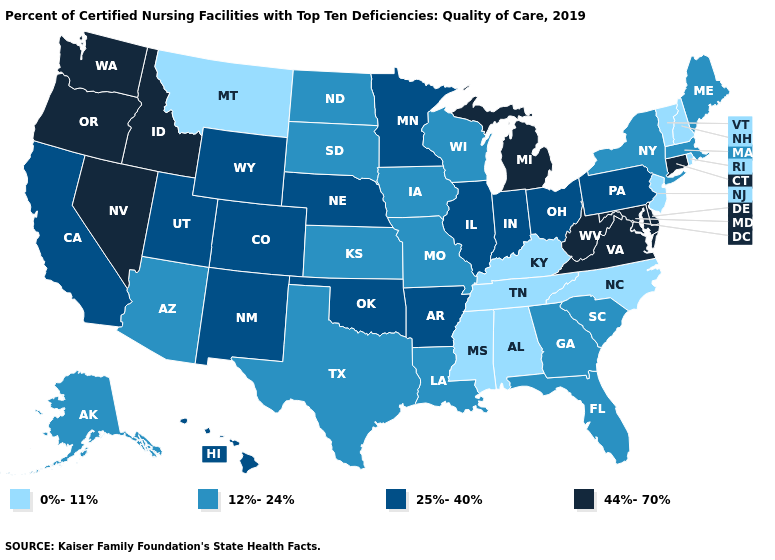Does New Jersey have the lowest value in the USA?
Keep it brief. Yes. Name the states that have a value in the range 44%-70%?
Be succinct. Connecticut, Delaware, Idaho, Maryland, Michigan, Nevada, Oregon, Virginia, Washington, West Virginia. Does Connecticut have the lowest value in the Northeast?
Write a very short answer. No. What is the value of Washington?
Keep it brief. 44%-70%. What is the value of Maryland?
Answer briefly. 44%-70%. Which states hav the highest value in the Northeast?
Answer briefly. Connecticut. Does Hawaii have the lowest value in the West?
Be succinct. No. What is the value of Utah?
Write a very short answer. 25%-40%. What is the lowest value in the West?
Short answer required. 0%-11%. How many symbols are there in the legend?
Be succinct. 4. Does Virginia have the lowest value in the South?
Write a very short answer. No. Does West Virginia have the same value as Kentucky?
Keep it brief. No. What is the value of California?
Concise answer only. 25%-40%. Which states hav the highest value in the Northeast?
Give a very brief answer. Connecticut. Does Virginia have the highest value in the South?
Answer briefly. Yes. 